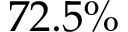<formula> <loc_0><loc_0><loc_500><loc_500>7 2 . 5 \%</formula> 